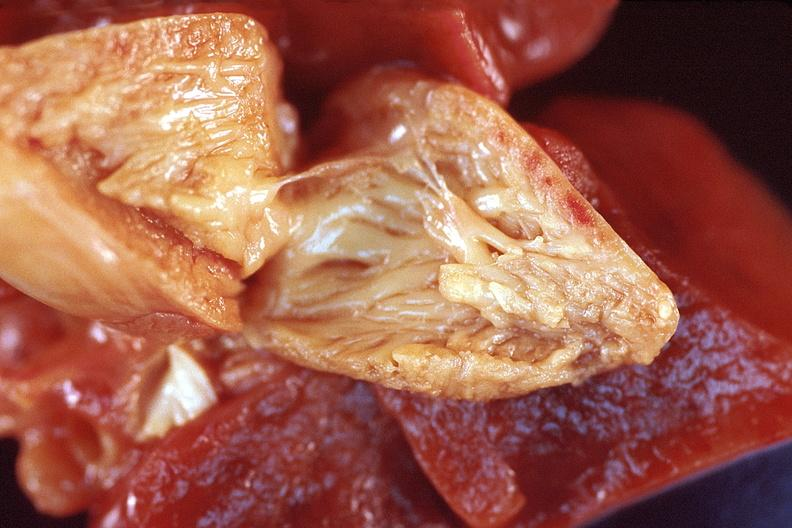s myocardium present?
Answer the question using a single word or phrase. No 